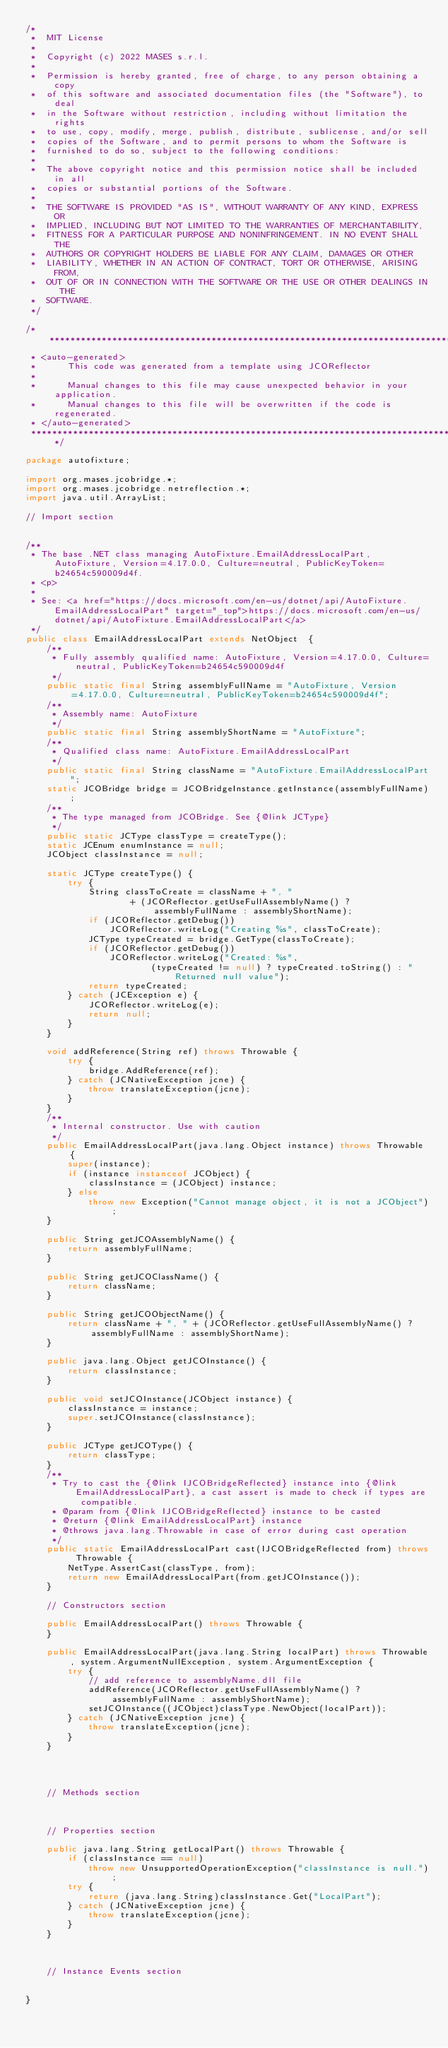Convert code to text. <code><loc_0><loc_0><loc_500><loc_500><_Java_>/*
 *  MIT License
 *
 *  Copyright (c) 2022 MASES s.r.l.
 *
 *  Permission is hereby granted, free of charge, to any person obtaining a copy
 *  of this software and associated documentation files (the "Software"), to deal
 *  in the Software without restriction, including without limitation the rights
 *  to use, copy, modify, merge, publish, distribute, sublicense, and/or sell
 *  copies of the Software, and to permit persons to whom the Software is
 *  furnished to do so, subject to the following conditions:
 *
 *  The above copyright notice and this permission notice shall be included in all
 *  copies or substantial portions of the Software.
 *
 *  THE SOFTWARE IS PROVIDED "AS IS", WITHOUT WARRANTY OF ANY KIND, EXPRESS OR
 *  IMPLIED, INCLUDING BUT NOT LIMITED TO THE WARRANTIES OF MERCHANTABILITY,
 *  FITNESS FOR A PARTICULAR PURPOSE AND NONINFRINGEMENT. IN NO EVENT SHALL THE
 *  AUTHORS OR COPYRIGHT HOLDERS BE LIABLE FOR ANY CLAIM, DAMAGES OR OTHER
 *  LIABILITY, WHETHER IN AN ACTION OF CONTRACT, TORT OR OTHERWISE, ARISING FROM,
 *  OUT OF OR IN CONNECTION WITH THE SOFTWARE OR THE USE OR OTHER DEALINGS IN THE
 *  SOFTWARE.
 */

/**************************************************************************************
 * <auto-generated>
 *      This code was generated from a template using JCOReflector
 * 
 *      Manual changes to this file may cause unexpected behavior in your application.
 *      Manual changes to this file will be overwritten if the code is regenerated.
 * </auto-generated>
 *************************************************************************************/

package autofixture;

import org.mases.jcobridge.*;
import org.mases.jcobridge.netreflection.*;
import java.util.ArrayList;

// Import section


/**
 * The base .NET class managing AutoFixture.EmailAddressLocalPart, AutoFixture, Version=4.17.0.0, Culture=neutral, PublicKeyToken=b24654c590009d4f.
 * <p>
 * 
 * See: <a href="https://docs.microsoft.com/en-us/dotnet/api/AutoFixture.EmailAddressLocalPart" target="_top">https://docs.microsoft.com/en-us/dotnet/api/AutoFixture.EmailAddressLocalPart</a>
 */
public class EmailAddressLocalPart extends NetObject  {
    /**
     * Fully assembly qualified name: AutoFixture, Version=4.17.0.0, Culture=neutral, PublicKeyToken=b24654c590009d4f
     */
    public static final String assemblyFullName = "AutoFixture, Version=4.17.0.0, Culture=neutral, PublicKeyToken=b24654c590009d4f";
    /**
     * Assembly name: AutoFixture
     */
    public static final String assemblyShortName = "AutoFixture";
    /**
     * Qualified class name: AutoFixture.EmailAddressLocalPart
     */
    public static final String className = "AutoFixture.EmailAddressLocalPart";
    static JCOBridge bridge = JCOBridgeInstance.getInstance(assemblyFullName);
    /**
     * The type managed from JCOBridge. See {@link JCType}
     */
    public static JCType classType = createType();
    static JCEnum enumInstance = null;
    JCObject classInstance = null;

    static JCType createType() {
        try {
            String classToCreate = className + ", "
                    + (JCOReflector.getUseFullAssemblyName() ? assemblyFullName : assemblyShortName);
            if (JCOReflector.getDebug())
                JCOReflector.writeLog("Creating %s", classToCreate);
            JCType typeCreated = bridge.GetType(classToCreate);
            if (JCOReflector.getDebug())
                JCOReflector.writeLog("Created: %s",
                        (typeCreated != null) ? typeCreated.toString() : "Returned null value");
            return typeCreated;
        } catch (JCException e) {
            JCOReflector.writeLog(e);
            return null;
        }
    }

    void addReference(String ref) throws Throwable {
        try {
            bridge.AddReference(ref);
        } catch (JCNativeException jcne) {
            throw translateException(jcne);
        }
    }
    /**
     * Internal constructor. Use with caution 
     */
    public EmailAddressLocalPart(java.lang.Object instance) throws Throwable {
        super(instance);
        if (instance instanceof JCObject) {
            classInstance = (JCObject) instance;
        } else
            throw new Exception("Cannot manage object, it is not a JCObject");
    }

    public String getJCOAssemblyName() {
        return assemblyFullName;
    }

    public String getJCOClassName() {
        return className;
    }

    public String getJCOObjectName() {
        return className + ", " + (JCOReflector.getUseFullAssemblyName() ? assemblyFullName : assemblyShortName);
    }

    public java.lang.Object getJCOInstance() {
        return classInstance;
    }

    public void setJCOInstance(JCObject instance) {
        classInstance = instance;
        super.setJCOInstance(classInstance);
    }

    public JCType getJCOType() {
        return classType;
    }
    /**
     * Try to cast the {@link IJCOBridgeReflected} instance into {@link EmailAddressLocalPart}, a cast assert is made to check if types are compatible.
     * @param from {@link IJCOBridgeReflected} instance to be casted
     * @return {@link EmailAddressLocalPart} instance
     * @throws java.lang.Throwable in case of error during cast operation
     */
    public static EmailAddressLocalPart cast(IJCOBridgeReflected from) throws Throwable {
        NetType.AssertCast(classType, from);
        return new EmailAddressLocalPart(from.getJCOInstance());
    }

    // Constructors section
    
    public EmailAddressLocalPart() throws Throwable {
    }

    public EmailAddressLocalPart(java.lang.String localPart) throws Throwable, system.ArgumentNullException, system.ArgumentException {
        try {
            // add reference to assemblyName.dll file
            addReference(JCOReflector.getUseFullAssemblyName() ? assemblyFullName : assemblyShortName);
            setJCOInstance((JCObject)classType.NewObject(localPart));
        } catch (JCNativeException jcne) {
            throw translateException(jcne);
        }
    }



    
    // Methods section
    

    
    // Properties section
    
    public java.lang.String getLocalPart() throws Throwable {
        if (classInstance == null)
            throw new UnsupportedOperationException("classInstance is null.");
        try {
            return (java.lang.String)classInstance.Get("LocalPart");
        } catch (JCNativeException jcne) {
            throw translateException(jcne);
        }
    }



    // Instance Events section
    

}</code> 